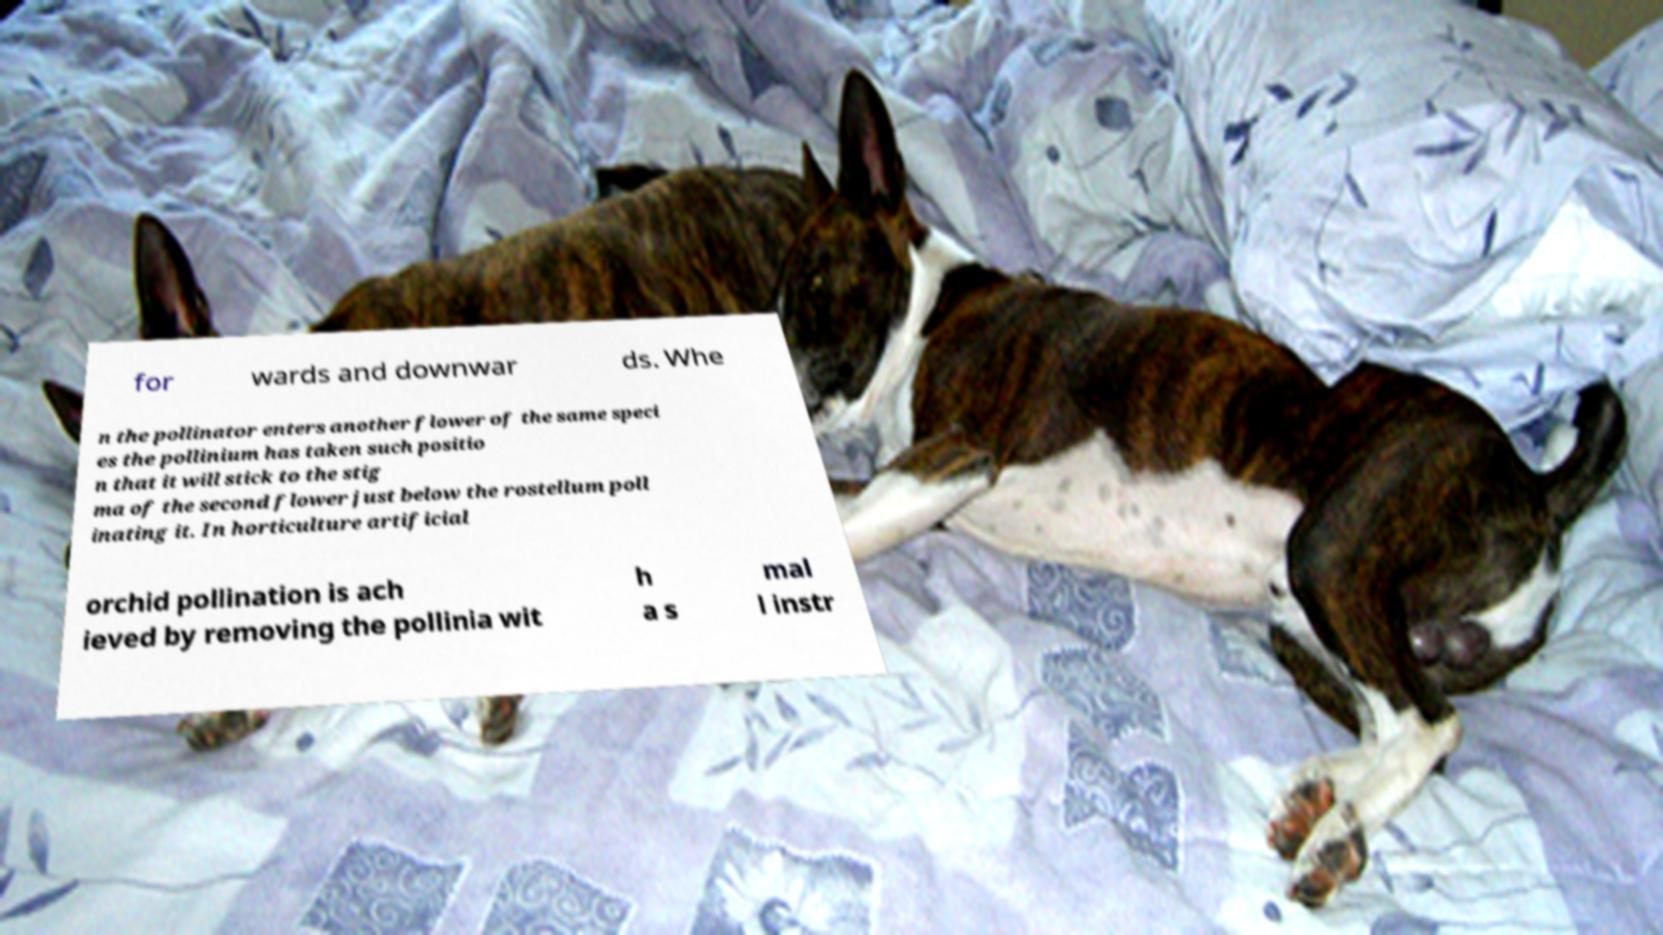Could you assist in decoding the text presented in this image and type it out clearly? for wards and downwar ds. Whe n the pollinator enters another flower of the same speci es the pollinium has taken such positio n that it will stick to the stig ma of the second flower just below the rostellum poll inating it. In horticulture artificial orchid pollination is ach ieved by removing the pollinia wit h a s mal l instr 